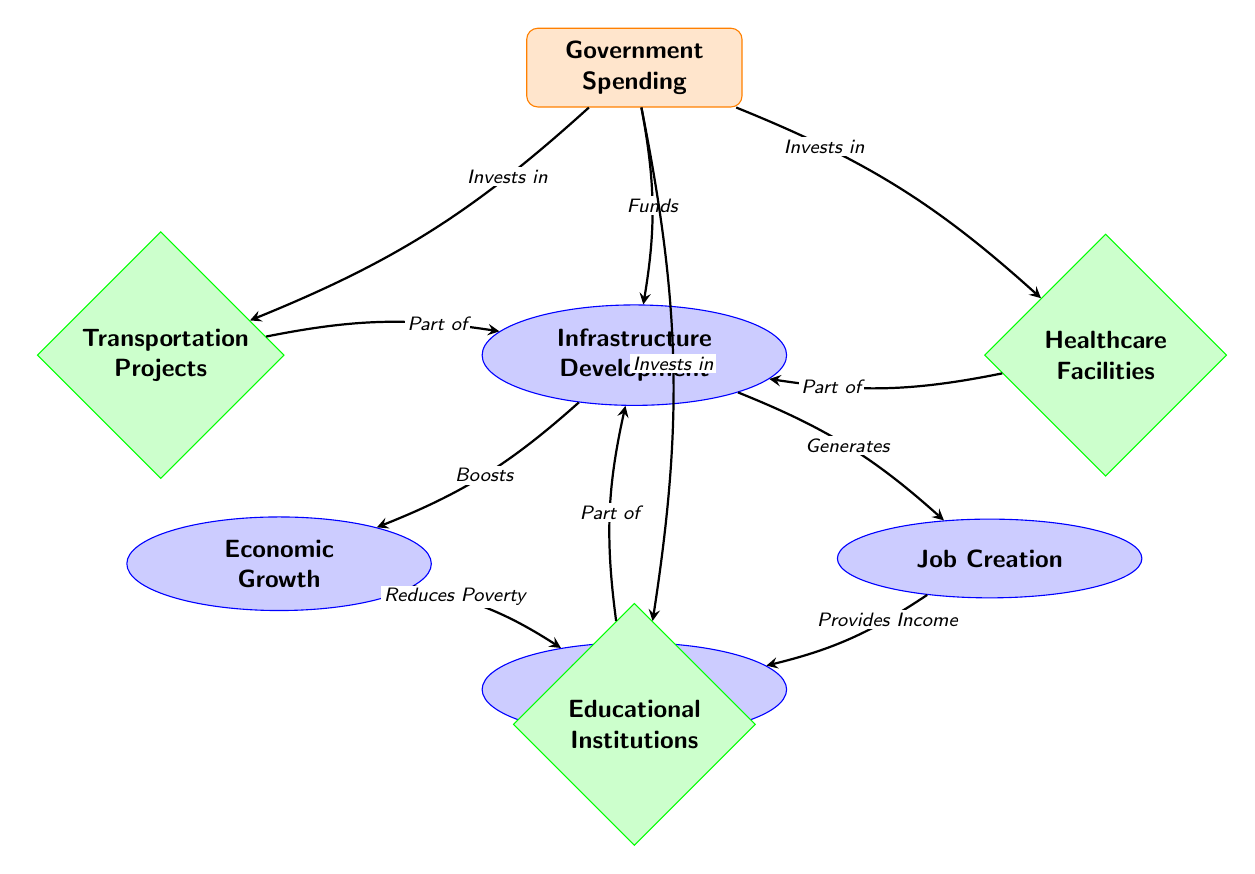What is the main factor represented at the top of the diagram? The top factor is labeled 'Government Spending', which is the initial node that influences the entire diagram.
Answer: Government Spending How many outcome nodes are represented in the diagram? There are four outcome nodes: Infrastructure Development, Economic Growth, Job Creation, and Poverty Alleviation.
Answer: 4 Which node does 'Infrastructure Development' point to directly? 'Infrastructure Development' directly points to 'Economic Growth' and 'Job Creation', representing the outcomes of improved infrastructure.
Answer: Economic Growth, Job Creation What type of projects does government spending invest in on the left side of the diagram? The left side of the diagram lists 'Transportation Projects', which are part of the investments made by government spending.
Answer: Transportation Projects Which two outcomes contribute to 'Poverty Alleviation'? 'Economic Growth' and 'Job Creation' both contribute to 'Poverty Alleviation' as indicated by the arrows pointing to this node.
Answer: Economic Growth, Job Creation How does 'Job Creation' affect 'Poverty Alleviation'? 'Job Creation' provides income to individuals, which is symbolized by the arrow indicating a direct effect on 'Poverty Alleviation'.
Answer: Provides Income What role does 'Infrastructure Development' play in the economic chain? 'Infrastructure Development' boosts economic growth and generates job creation, acting as a catalyst for both outcomes.
Answer: Catalyst What is the relationship between 'Government Spending' and 'Healthcare Facilities'? 'Government Spending' invests in 'Healthcare Facilities' as indicated by the directed arrow from 'Government Spending' to 'Healthcare Facilities'.
Answer: Invests in How many distinct investments are listed in the diagram? There are three distinct investment nodes: Transportation Projects, Healthcare Facilities, and Educational Institutions.
Answer: 3 Which outcome is positioned furthest below in the diagram layout? 'Poverty Alleviation' is positioned furthest below in the diagram layout, indicating it is an ultimate goal resulting from the preceding interactions.
Answer: Poverty Alleviation 